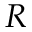Convert formula to latex. <formula><loc_0><loc_0><loc_500><loc_500>R</formula> 